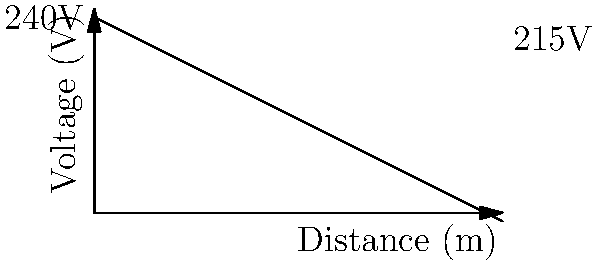As a property manager overseeing a large commercial property, you need to assess the voltage drop across a long electrical cable run. The voltage at the source is 240V, and at the end of a 500m cable, it drops to 215V. What is the voltage drop per meter of cable? To solve this problem, we need to follow these steps:

1. Calculate the total voltage drop:
   $\text{Total drop} = 240V - 215V = 25V$

2. Determine the length of the cable:
   $\text{Cable length} = 500m$

3. Calculate the voltage drop per meter:
   $\text{Drop per meter} = \frac{\text{Total drop}}{\text{Cable length}}$
   
   $\text{Drop per meter} = \frac{25V}{500m} = 0.05 V/m$

4. Convert to millivolts for a more practical unit:
   $0.05 V/m \times 1000 mV/V = 50 mV/m$

Therefore, the voltage drop per meter of cable is 50 mV/m or 0.05 V/m.
Answer: 50 mV/m 